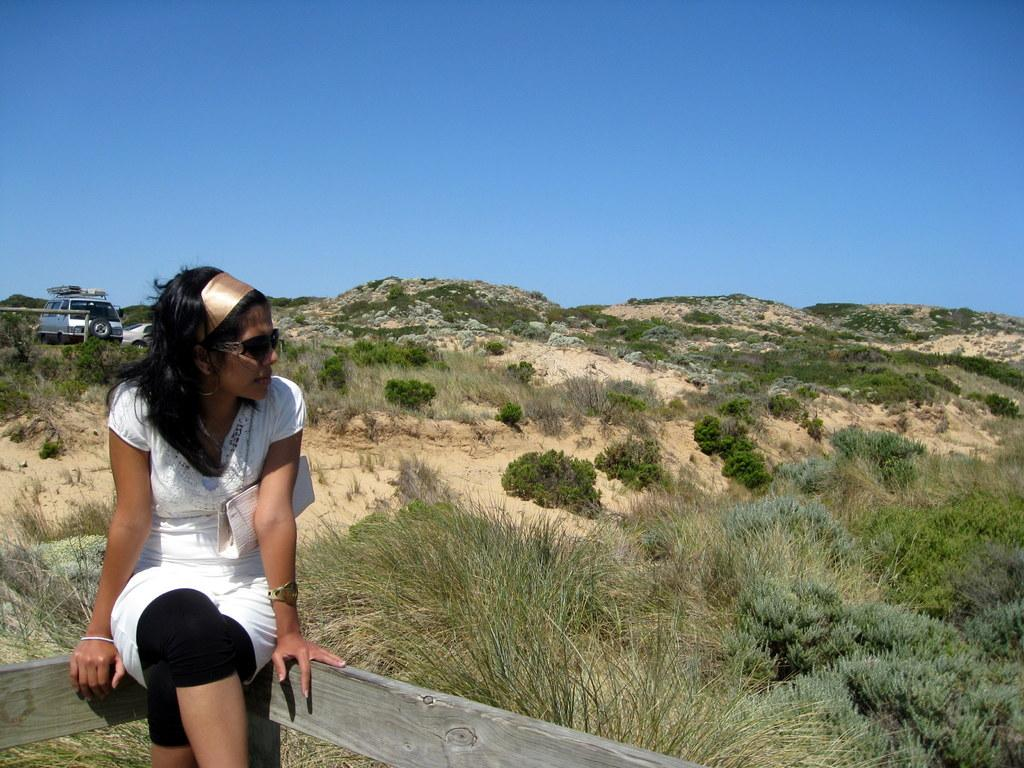Who is present in the image? There is a woman in the image. What is the woman doing in the image? The woman is sitting. What is the woman wearing that is related to her activity? The woman is wearing goggles. What type of natural elements can be seen in the image? There are plants in the image. What type of man-made objects can be seen in the image? There are vehicles in the image. What is visible in the background of the image? The sky is visible in the image. What type of toy can be seen in the woman's hand in the image? There is no toy visible in the woman's hand in the image. What type of home is shown in the background of the image? There is no home visible in the background of the image. 